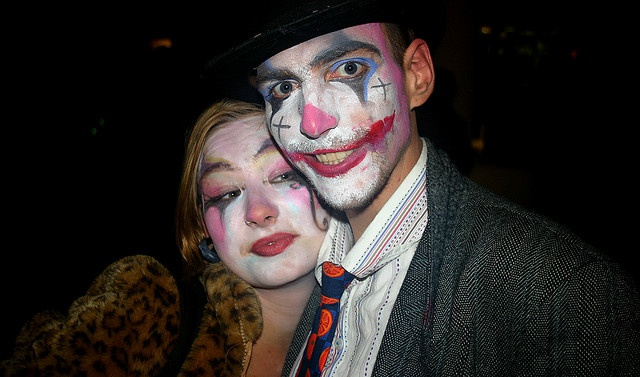Describe the objects in this image and their specific colors. I can see people in black, lightgray, gray, and darkgray tones, people in black, darkgray, maroon, and gray tones, and tie in black, navy, brown, and maroon tones in this image. 